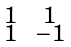<formula> <loc_0><loc_0><loc_500><loc_500>\begin{smallmatrix} 1 & & 1 \\ 1 & & - 1 \end{smallmatrix}</formula> 